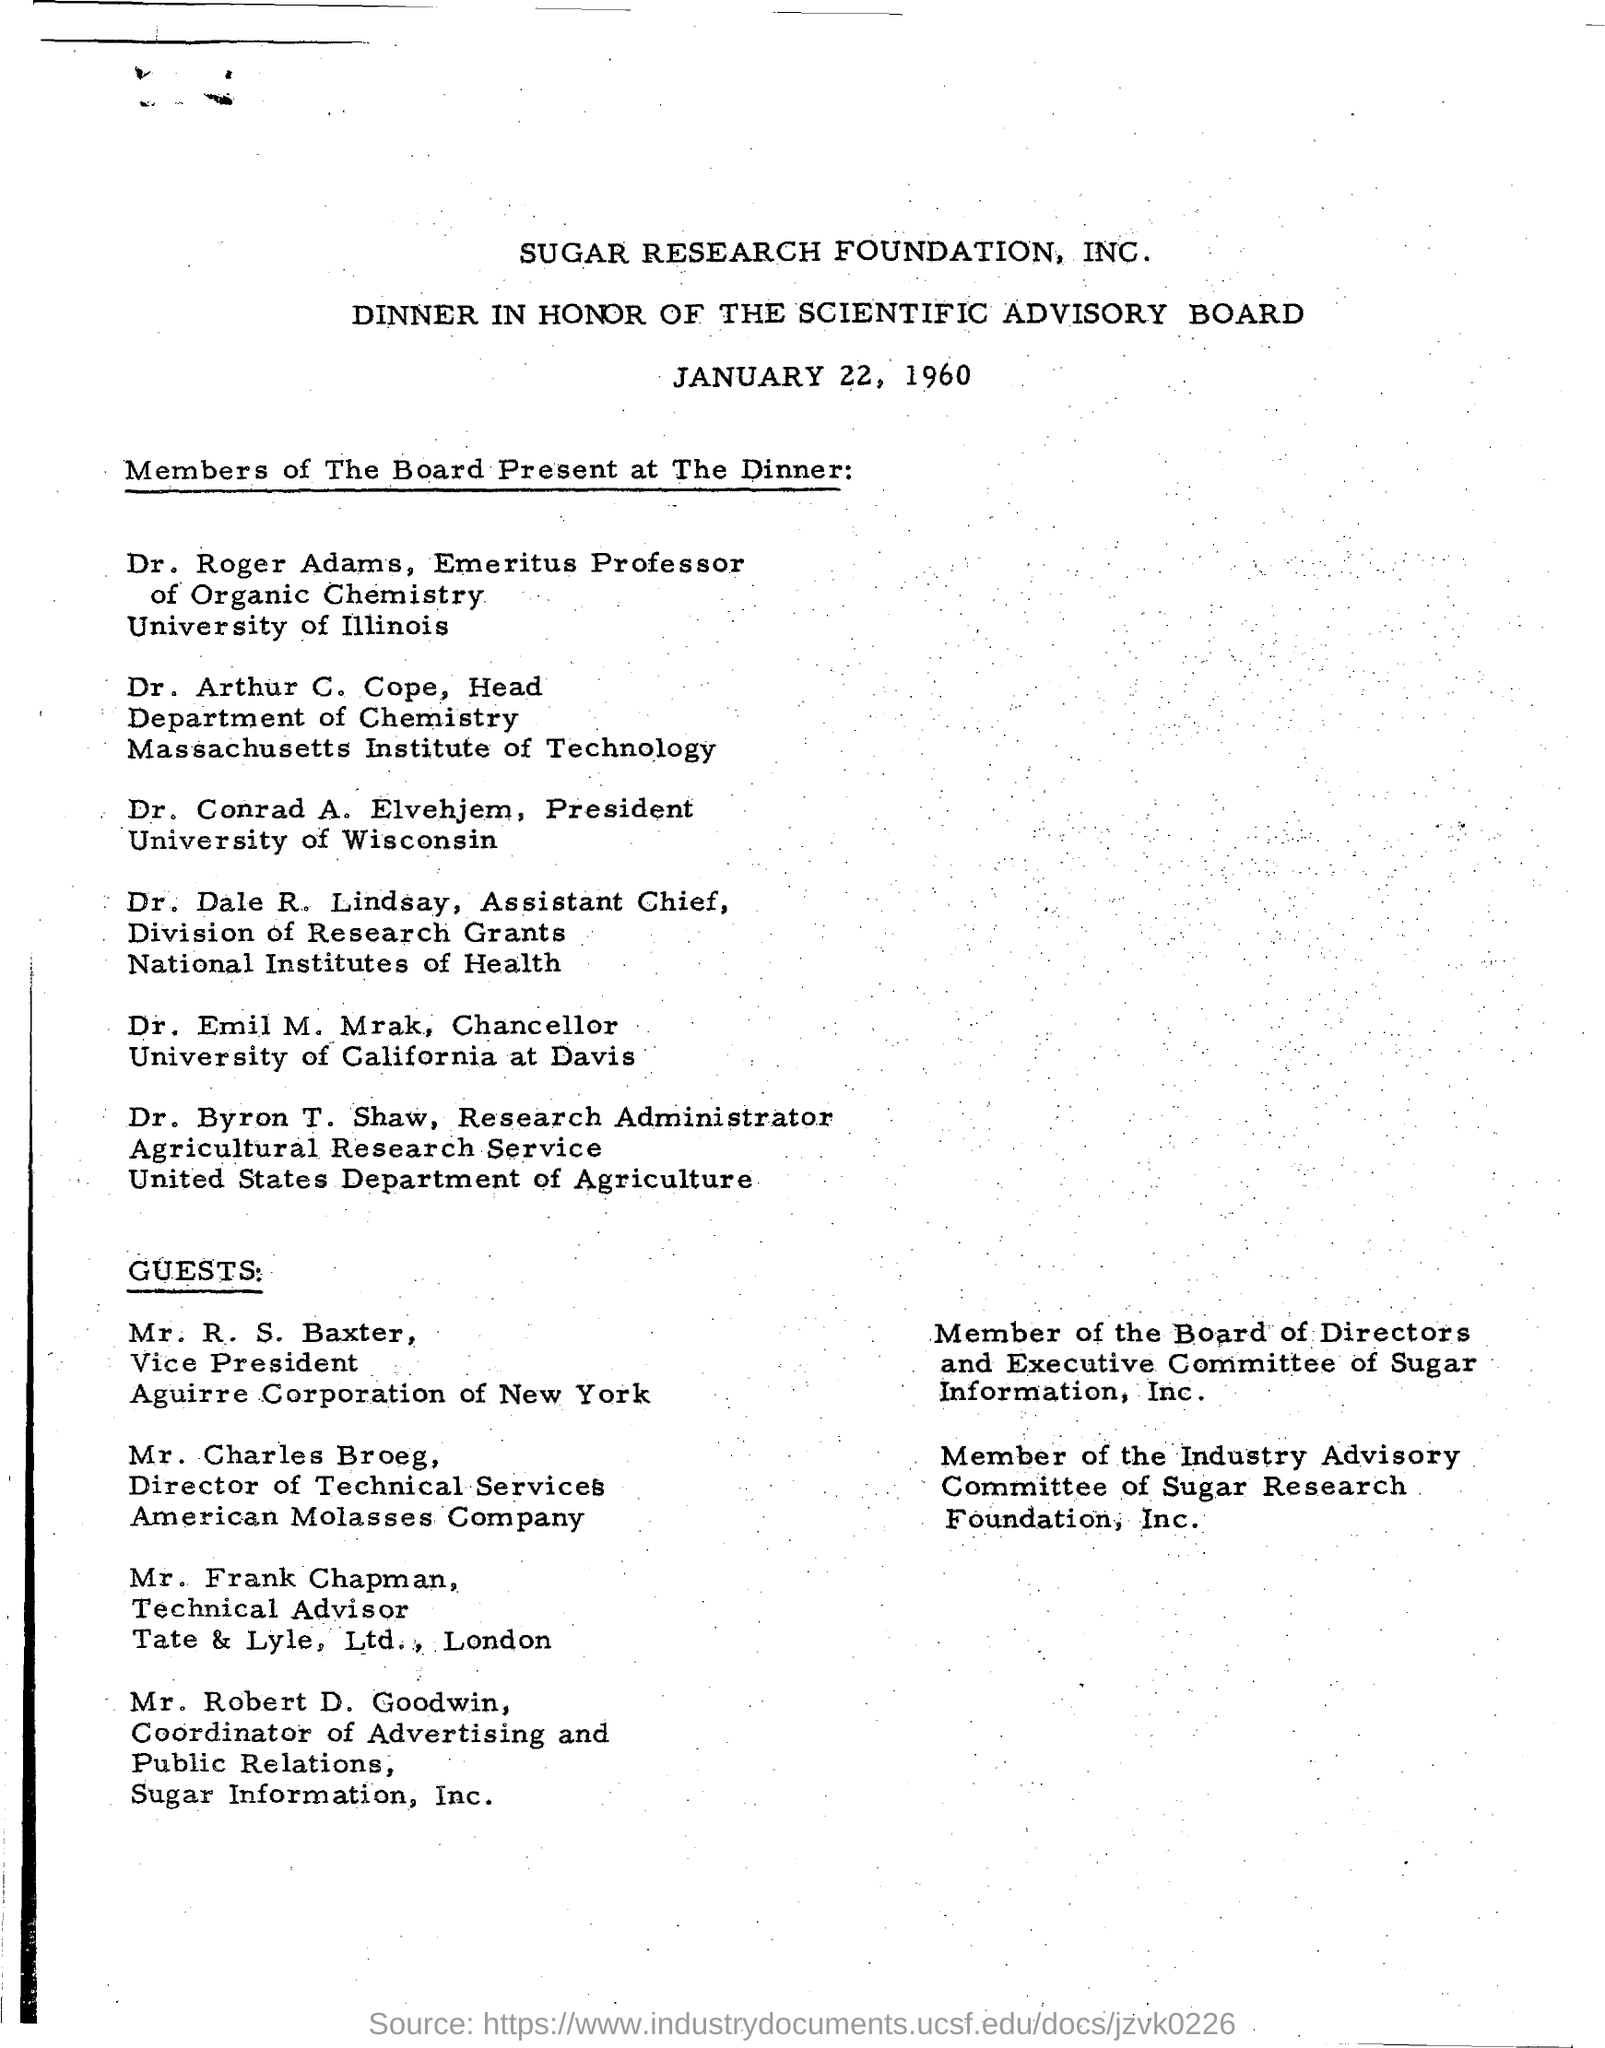Point out several critical features in this image. Dr. Emil M. Mrak holds the designation of Chancellor. Dr. Byron T. Shaw holds the designation of research administrator. The dinner is scheduled for January 22, 1960. 